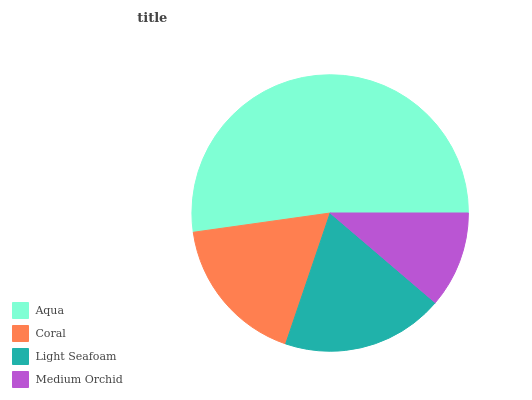Is Medium Orchid the minimum?
Answer yes or no. Yes. Is Aqua the maximum?
Answer yes or no. Yes. Is Coral the minimum?
Answer yes or no. No. Is Coral the maximum?
Answer yes or no. No. Is Aqua greater than Coral?
Answer yes or no. Yes. Is Coral less than Aqua?
Answer yes or no. Yes. Is Coral greater than Aqua?
Answer yes or no. No. Is Aqua less than Coral?
Answer yes or no. No. Is Light Seafoam the high median?
Answer yes or no. Yes. Is Coral the low median?
Answer yes or no. Yes. Is Coral the high median?
Answer yes or no. No. Is Aqua the low median?
Answer yes or no. No. 